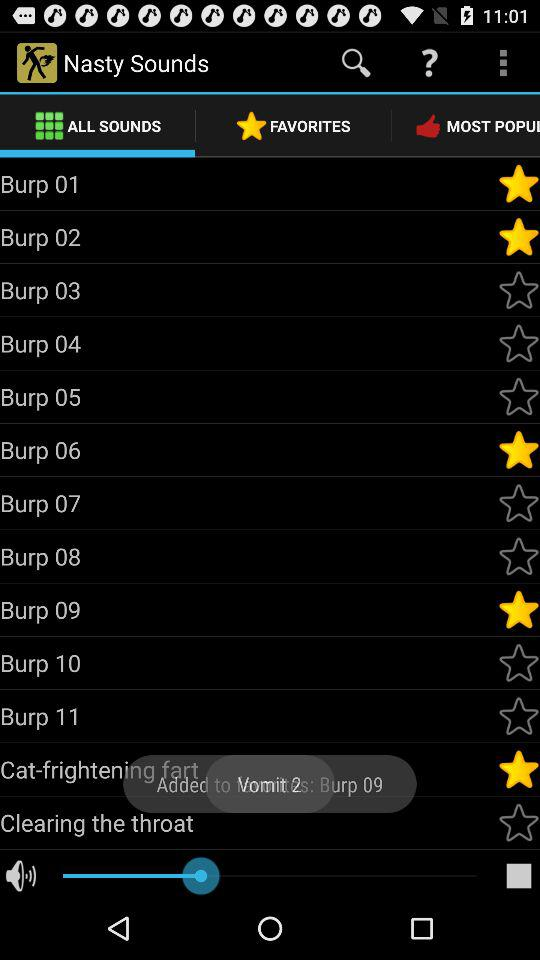Which sounds are marked as favorites in "Nasty Sounds"? The sounds are "Burp 01", "Burp 02", "Burp 06", "Burp 09" and "Cat-frightening fart". 